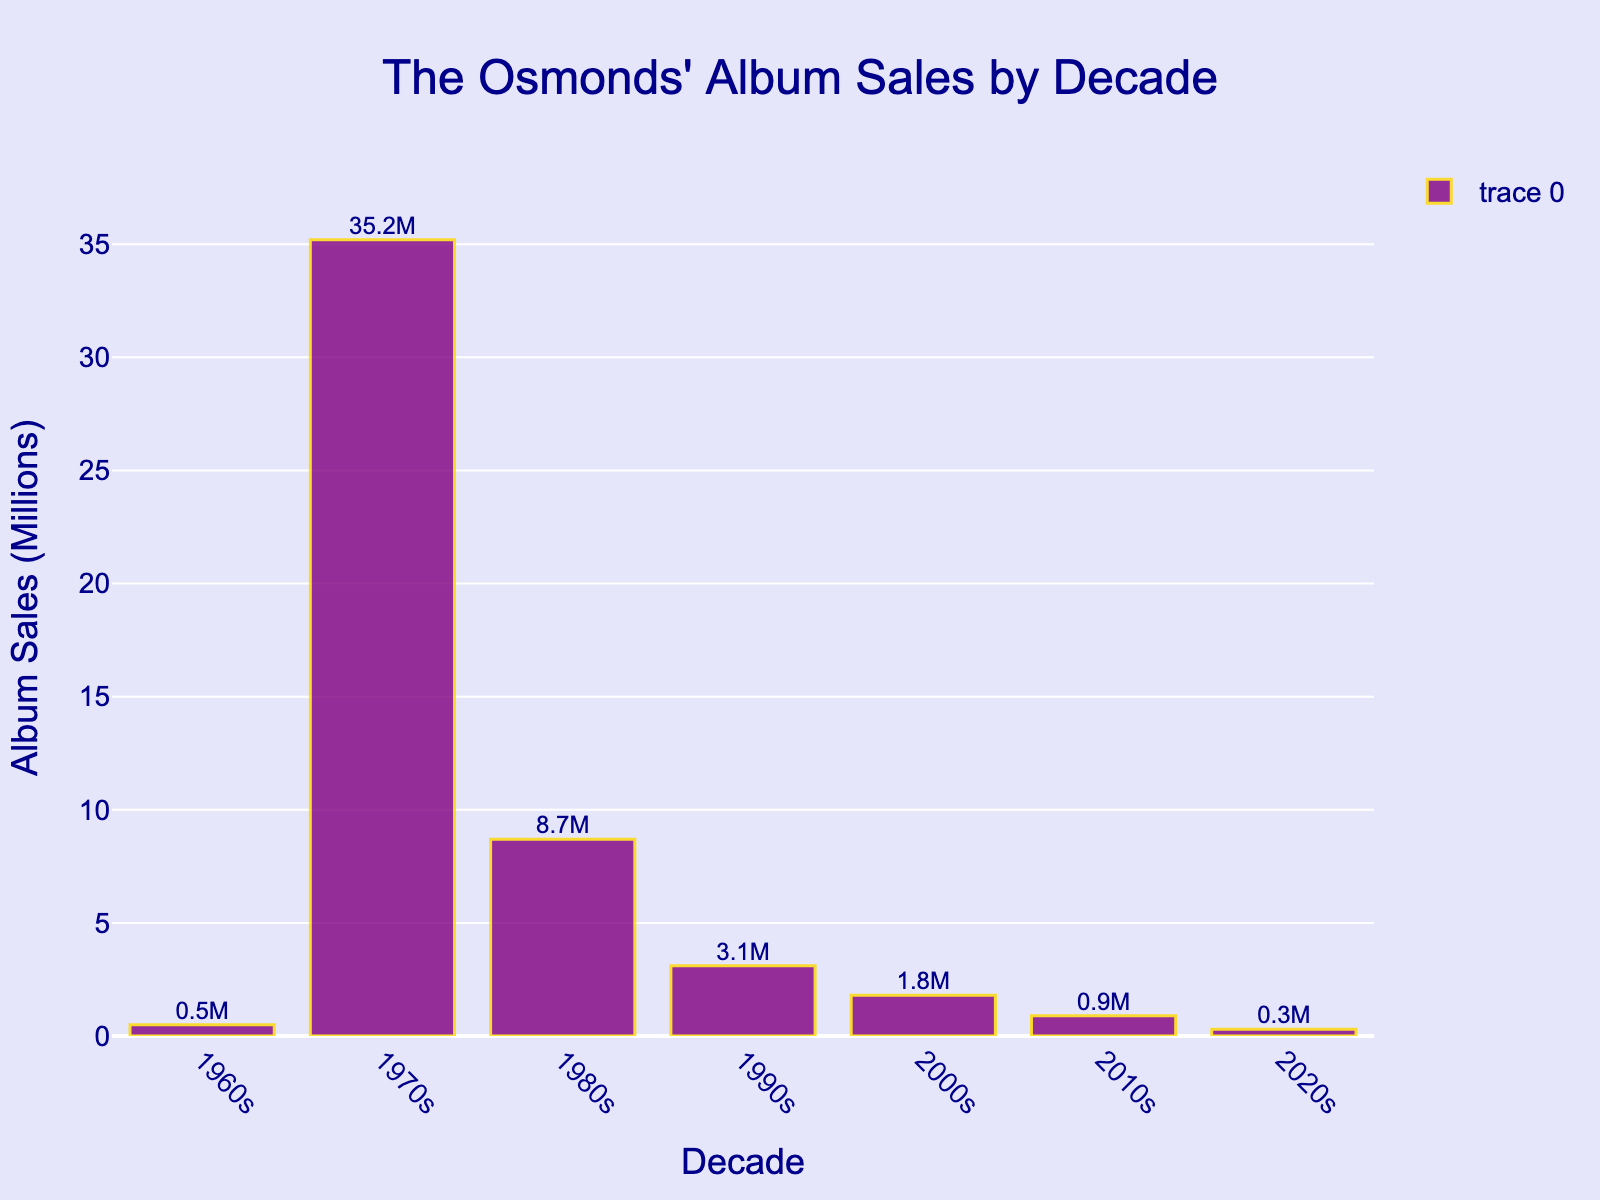Which decade had the highest album sales for the Osmonds? To determine the decade with the highest album sales, look at the heights of the bars in the plot. The tallest bar represents the 1970s.
Answer: The 1970s What was the total album sales across all decades shown in the chart? Add up the album sales from each decade: 0.5 (1960s) + 35.2 (1970s) + 8.7 (1980s) + 3.1 (1990s) + 1.8 (2000s) + 0.9 (2010s) + 0.3 (2020s) = 50.5 million.
Answer: 50.5 million How do the album sales of the 1980s compare to the 1990s? Compare the heights of the bars for the 1980s and the 1990s. The bar for the 1980s is taller than the bar for the 1990s, indicating higher album sales in the 1980s.
Answer: The 1980s had higher sales What is the average album sales per decade? To find the average album sales per decade, add up all the album sales and divide by the number of decades: (0.5 + 35.2 + 8.7 + 3.1 + 1.8 + 0.9 + 0.3) / 7 = 50.5 / 7 ≈ 7.21 million.
Answer: 7.21 million By how much did album sales decrease between the 1970s and the 1980s? Subtract the album sales in the 1980s from the 1970s: 35.2 (1970s) - 8.7 (1980s) = 26.5 million.
Answer: 26.5 million Which decade had nearly twice the album sales of the 2000s? Look for a decade with album sales close to twice that of the 2000s (1.8 million). The 1980s had 8.7 million, which is close to twice 1.8 million (1.8 * 2 = 3.6, and 8.7 is approximately twice 3.6).
Answer: The 1980s What is the ratio of album sales in the 1970s to the 2020s? Divide the album sales in the 1970s by those in the 2020s: 35.2 / 0.3 ≈ 117.33.
Answer: Approximately 117:1 Which decade had the smallest album sales, and what was the value? Identify the shortest bar in the chart, representing the 2020s with 0.3 million sales.
Answer: The 2020s, 0.3 million What percent of the total album sales were achieved in the 1970s? Calculate the percentage of total album sales achieved in the 1970s: (35.2 / 50.5) * 100 ≈ 69.7%.
Answer: Approximately 69.7% 